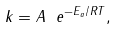Convert formula to latex. <formula><loc_0><loc_0><loc_500><loc_500>k = A \ e ^ { - E _ { a } / R T } ,</formula> 